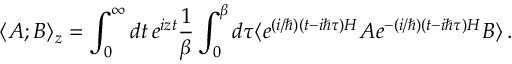<formula> <loc_0><loc_0><loc_500><loc_500>\langle A ; B \rangle _ { z } = \int _ { 0 } ^ { \infty } d t \, e ^ { i z t } \frac { 1 } { \beta } \int _ { 0 } ^ { \beta } d \tau \langle e ^ { ( i / \hbar { ) } ( t - i \hbar { \tau } ) H } A e ^ { - ( i / \hbar { ) } ( t - i \hbar { \tau } ) H } B \rangle \, .</formula> 